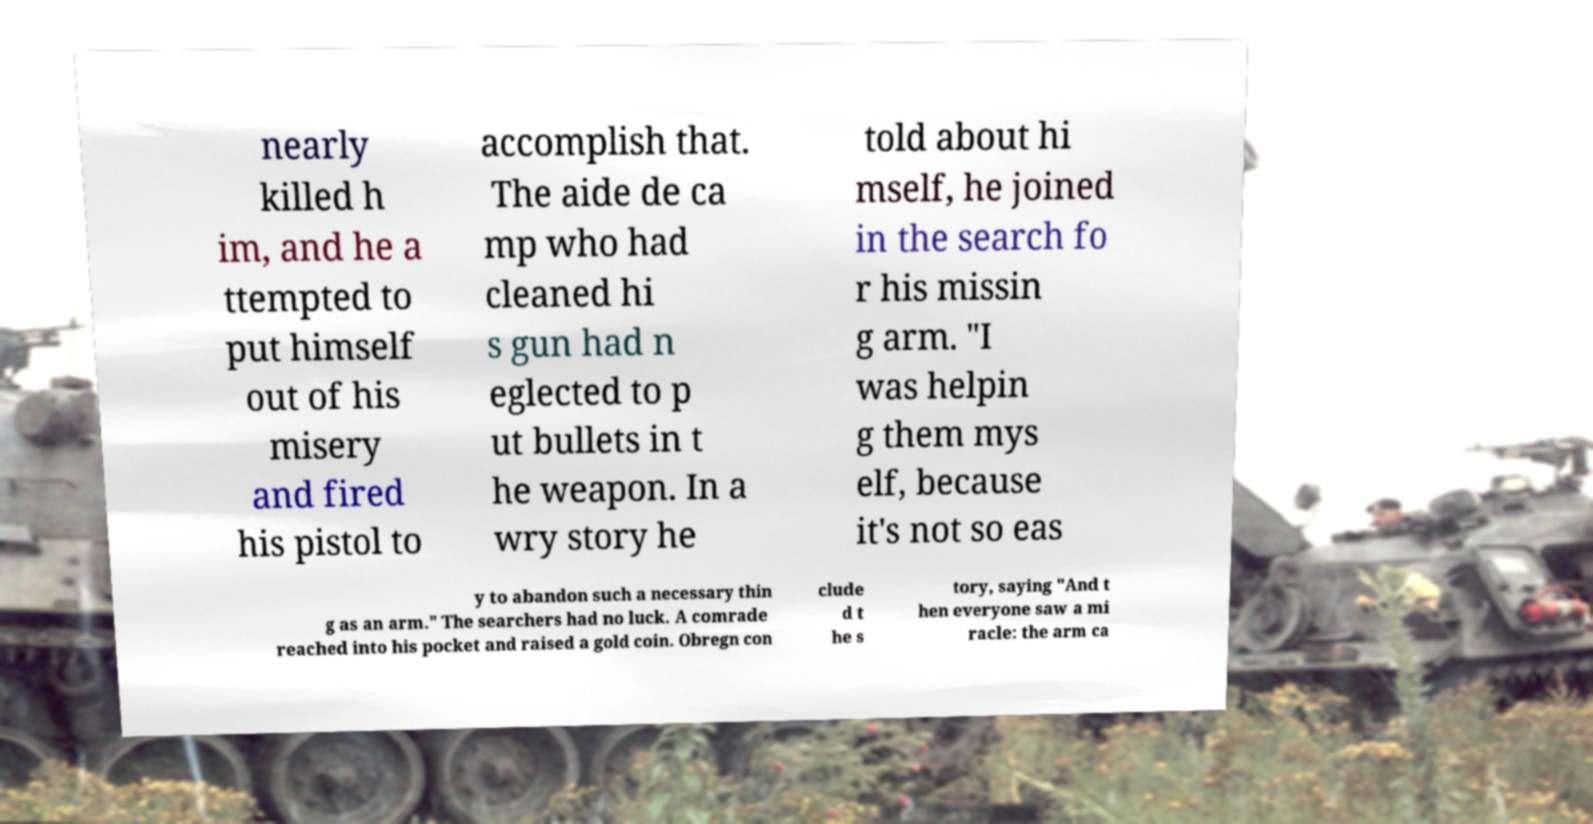Could you extract and type out the text from this image? nearly killed h im, and he a ttempted to put himself out of his misery and fired his pistol to accomplish that. The aide de ca mp who had cleaned hi s gun had n eglected to p ut bullets in t he weapon. In a wry story he told about hi mself, he joined in the search fo r his missin g arm. "I was helpin g them mys elf, because it's not so eas y to abandon such a necessary thin g as an arm." The searchers had no luck. A comrade reached into his pocket and raised a gold coin. Obregn con clude d t he s tory, saying "And t hen everyone saw a mi racle: the arm ca 